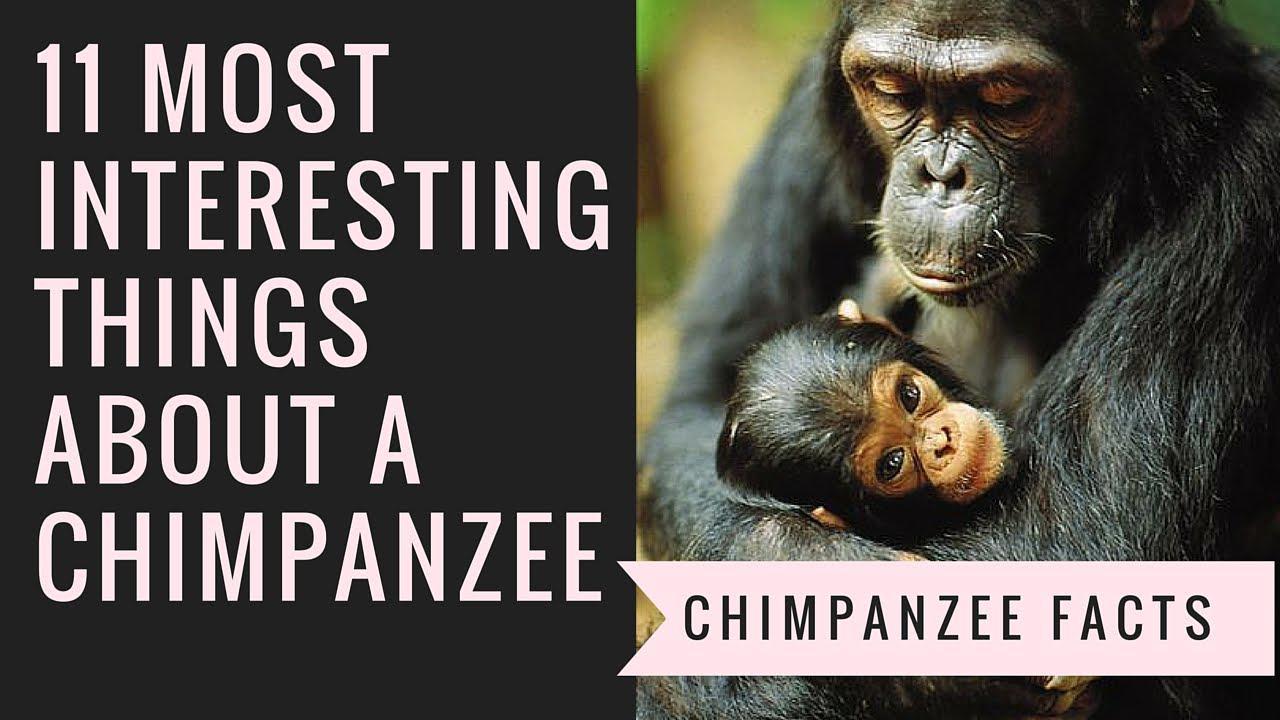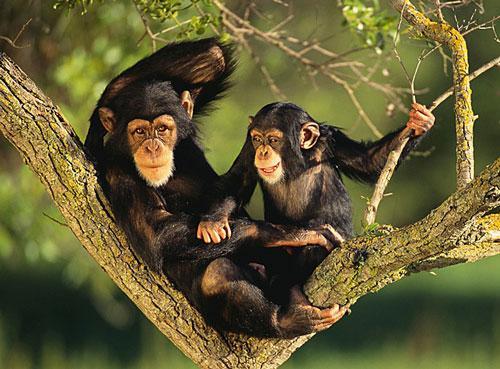The first image is the image on the left, the second image is the image on the right. Assess this claim about the two images: "There is a single chimp outdoors in each of the images.". Correct or not? Answer yes or no. No. The first image is the image on the left, the second image is the image on the right. For the images shown, is this caption "The right image contains exactly one chimpanzee." true? Answer yes or no. No. 